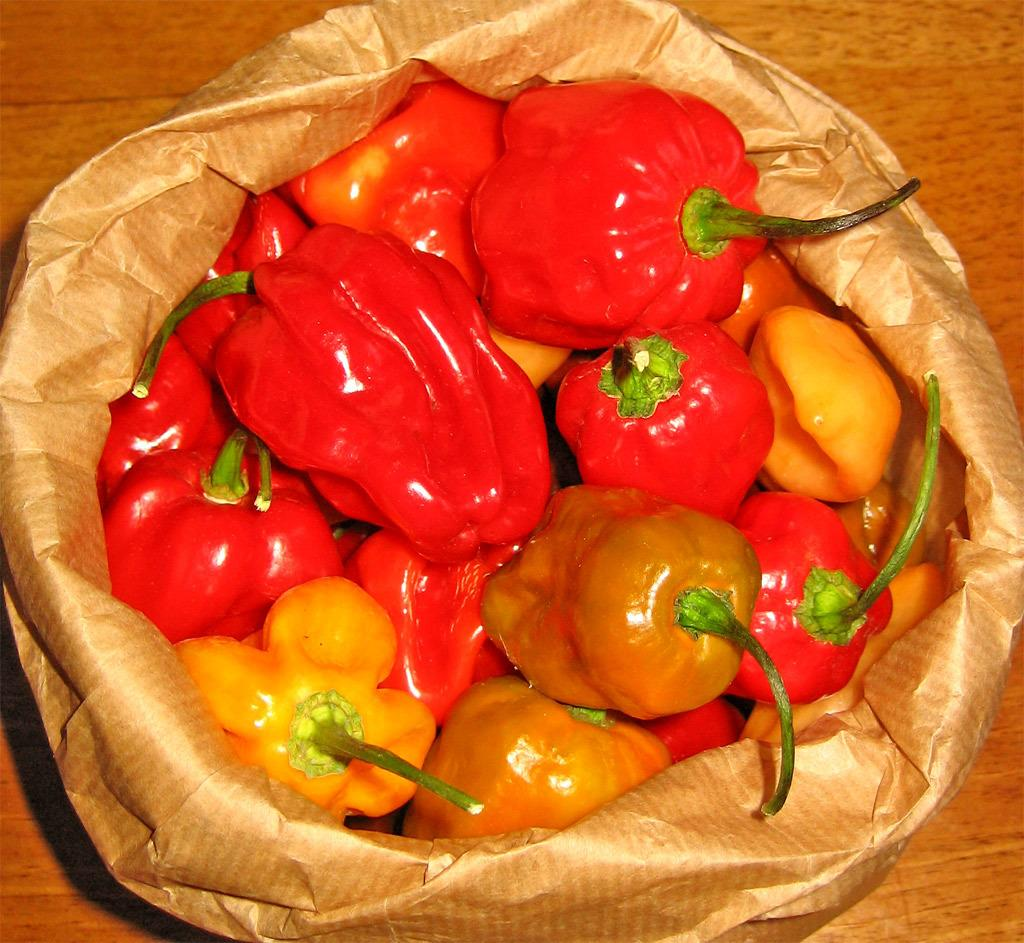What type of food is featured in the image? There are big red chilies in the image. How are the chilies being stored or transported? The chilies are in a bag. What type of street is visible in the image? There is no street visible in the image; it features big red chilies in a bag. What type of eggnog is being served in the image? There is no eggnog present in the image; it features big red chilies in a bag. 